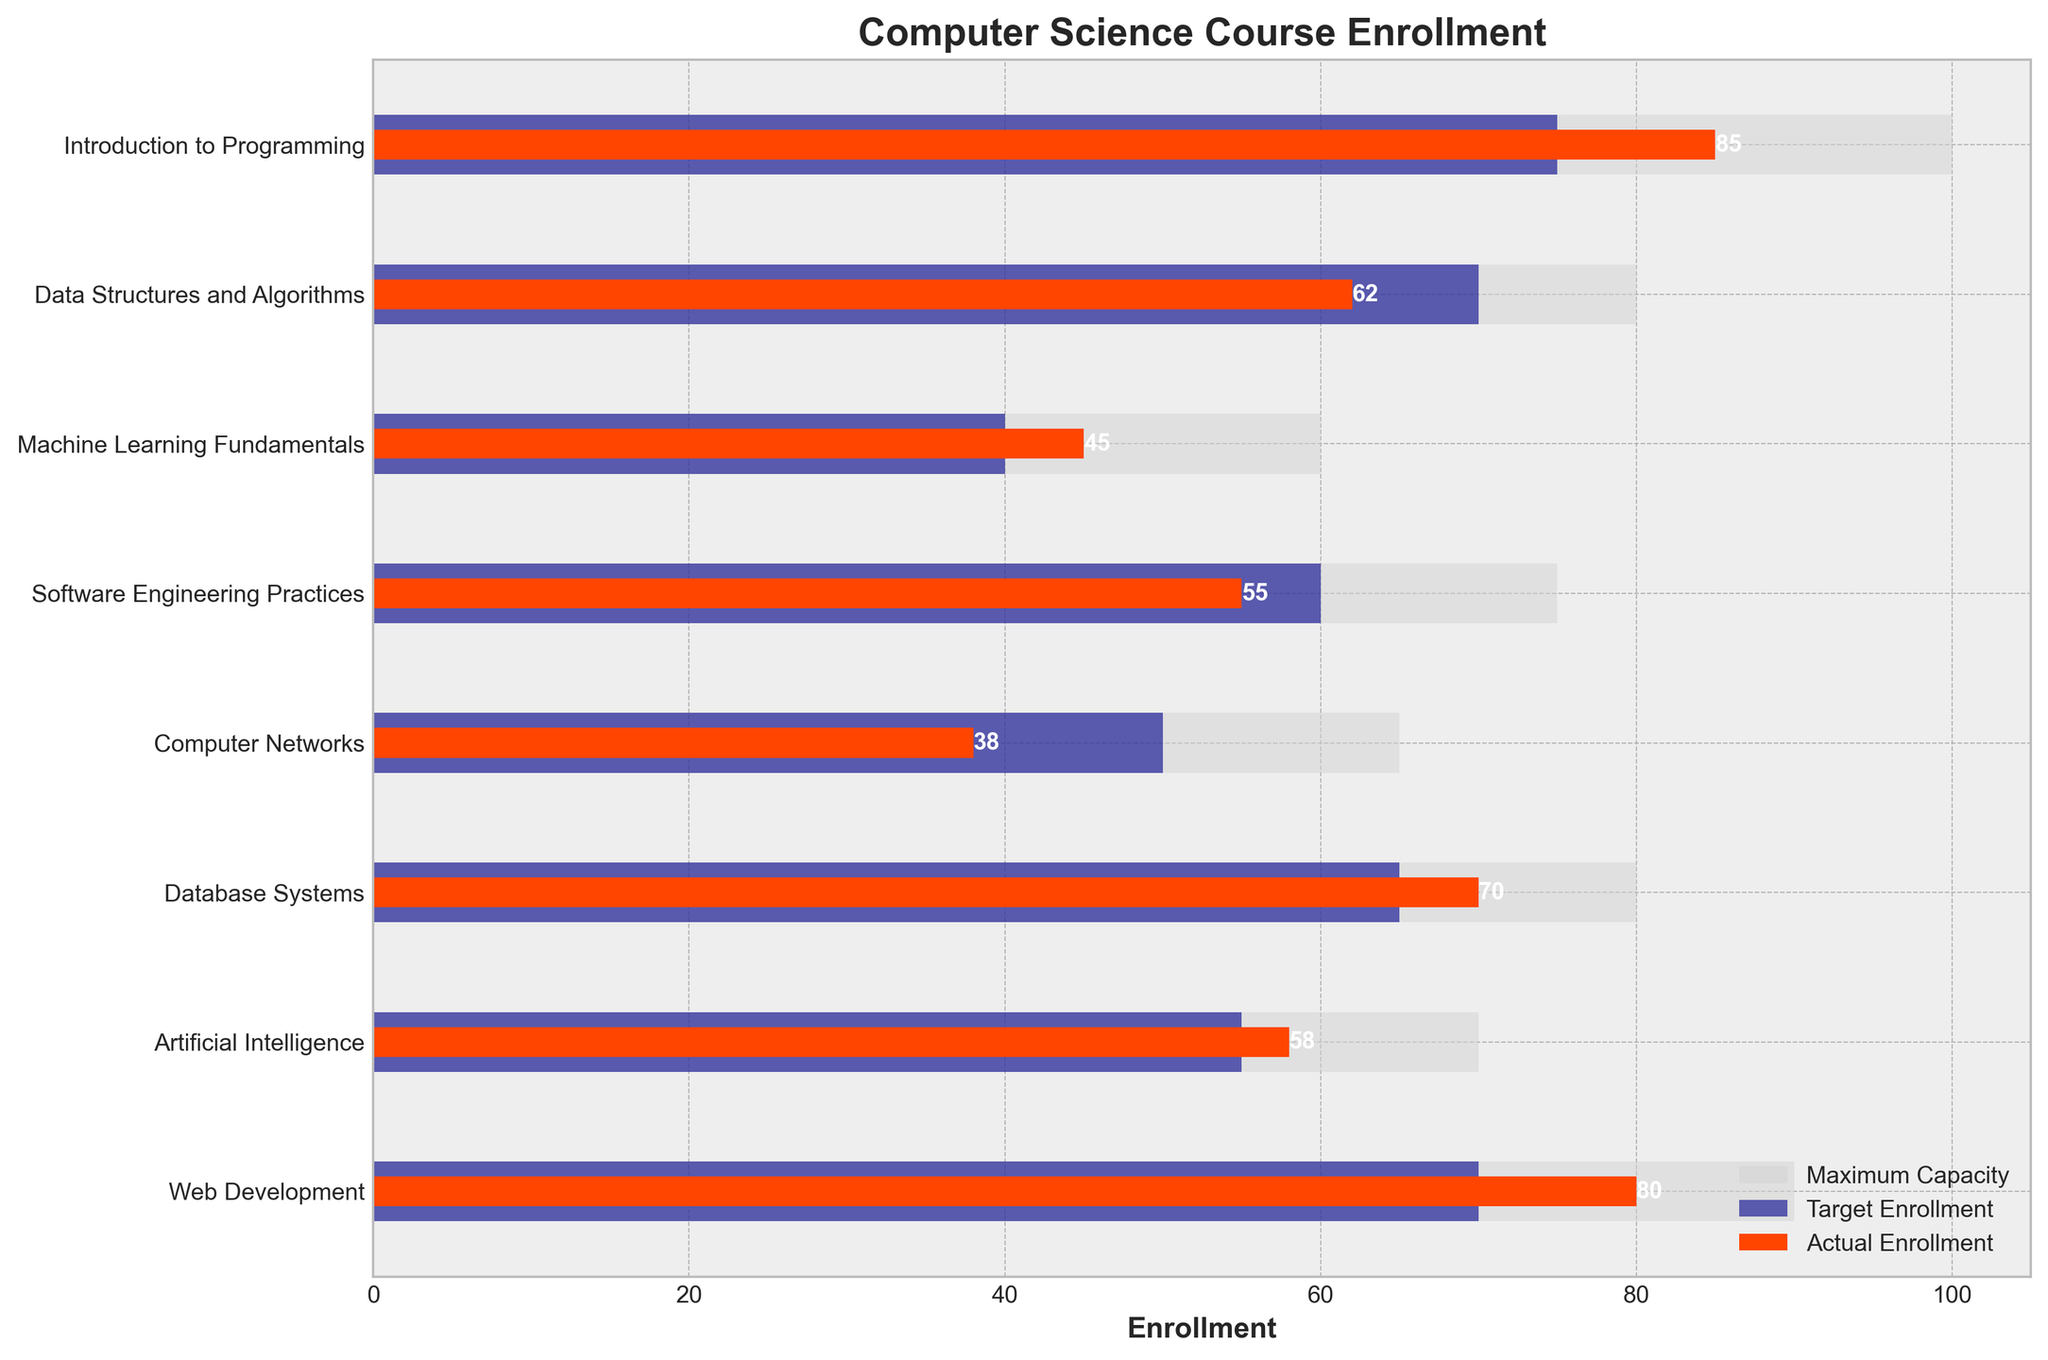What's the title of the plot? The title is typically located at the top of the plot for easy identification. In this case, the title provided specifies the main focus.
Answer: Computer Science Course Enrollment Which course has the highest actual enrollment? By examining the red bar lengths representing actual enrollment for each course, it is clear which one extends the furthest.
Answer: Introduction to Programming What is the enrollment target for Web Development? The dark blue bar represents the target enrollment. For Web Development, observe where the end of the dark blue bar aligns on the enrollment axis.
Answer: 70 Which course has the largest difference between actual enrollment and target enrollment? Calculate the difference for each course by subtracting the target enrollment (dark blue bar) from the actual enrollment (red bar). The course with the largest positive value is the answer.
Answer: Introduction to Programming What is the maximum capacity for Machine Learning Fundamentals? Identify the light grey bar, which indicates maximum capacity, and find the corresponding value for Machine Learning Fundamentals.
Answer: 60 Is any course over the maximum capacity? Check if the red bar (actual enrollment) surpasses the light grey bar (maximum capacity) for any course.
Answer: No Which course exceeds its target enrollment by the largest margin? Calculate the difference for each course by subtracting the target enrollment (dark blue bar) from the actual enrollment (red bar). The largest positive difference identifies this course.
Answer: Introduction to Programming Which course has the lowest actual enrollment? Identify the shortest red bar among all courses.
Answer: Computer Networks What is the total target enrollment for all courses? Add up the values of the target enrollments (dark blue bars) for all courses. The sum will be the total target enrollment.
Answer: 485 In which courses does the actual enrollment equal the target enrollment? Compare the length of the red and dark blue bars for each course. If the bars match in any courses, those are your answers.
Answer: None 